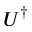<formula> <loc_0><loc_0><loc_500><loc_500>U ^ { \dagger }</formula> 